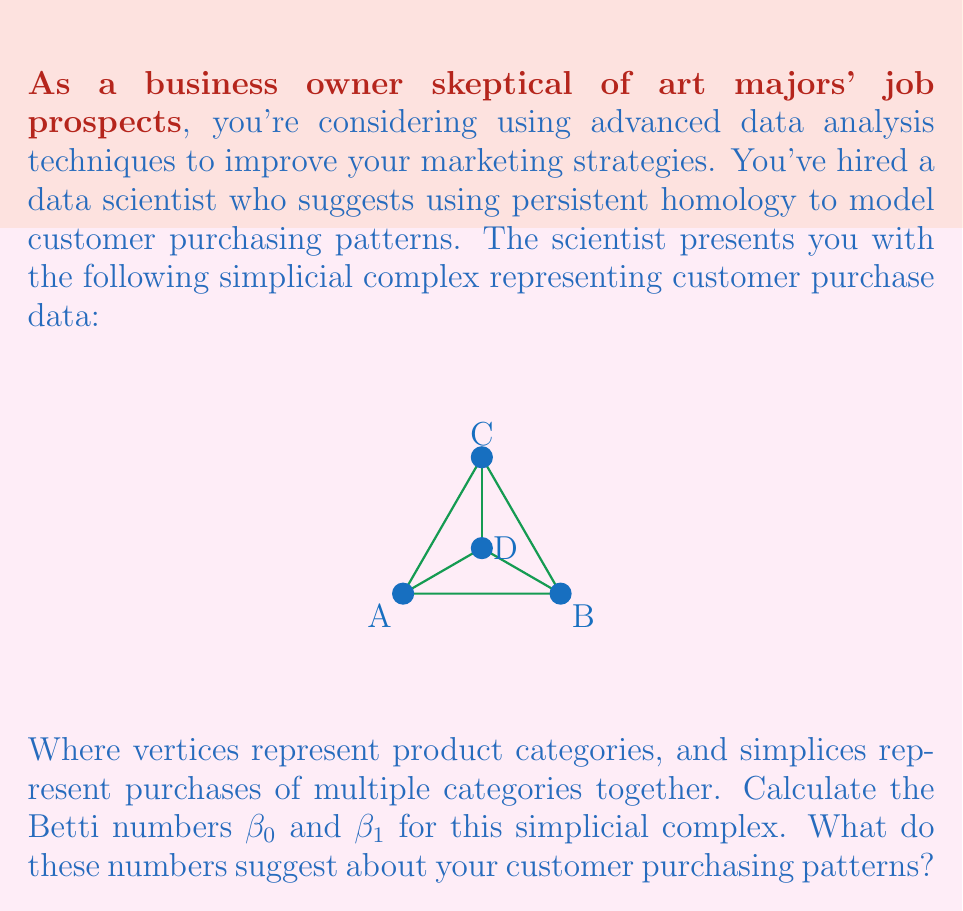Provide a solution to this math problem. To calculate the Betti numbers, we need to analyze the structure of the simplicial complex:

1. First, let's count the components:
   - The complex is connected, so there is only one component.
   - Therefore, $\beta_0 = 1$

2. Now, let's count the holes:
   - There is one triangular hole (ACD) in the complex.
   - Therefore, $\beta_1 = 1$

3. Interpretation of Betti numbers:
   - $\beta_0 = 1$ indicates that all product categories are connected in some way through customer purchases.
   - $\beta_1 = 1$ suggests that there is one significant purchasing pattern that forms a cycle or loop among product categories.

4. Business implications:
   - The connected nature ($\beta_0 = 1$) implies that customers tend to purchase across different product categories, which is good for cross-selling opportunities.
   - The presence of a hole ($\beta_1 = 1$) suggests that there might be a missed opportunity or a gap in your product offerings that could be filled to complete the cycle.

5. Marketing strategy:
   - Focus on strengthening the connections between product categories to maintain the single component.
   - Investigate the hole to determine if there's a potential new product or marketing strategy that could bridge this gap in customer purchasing patterns.
Answer: $\beta_0 = 1$, $\beta_1 = 1$; indicating connected categories with one significant cyclic purchasing pattern. 